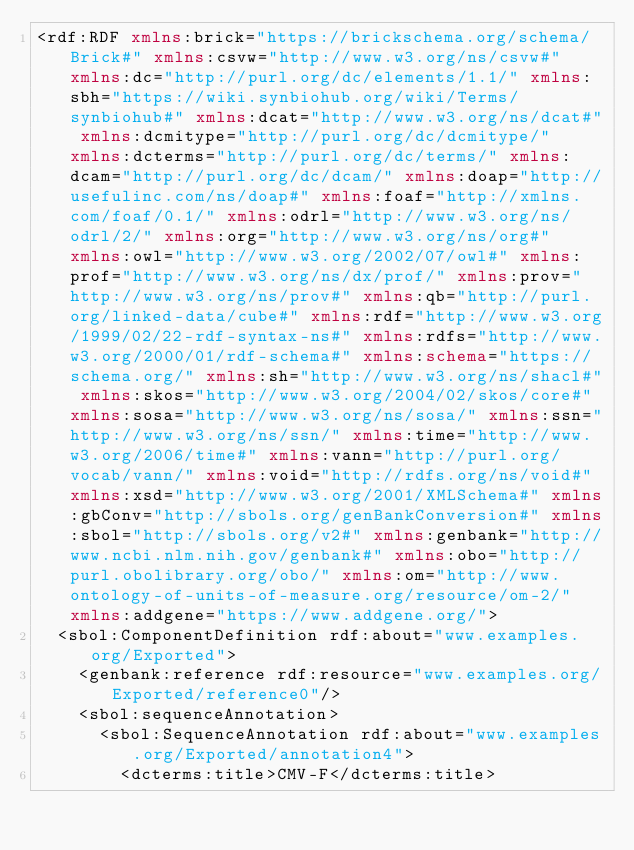<code> <loc_0><loc_0><loc_500><loc_500><_XML_><rdf:RDF xmlns:brick="https://brickschema.org/schema/Brick#" xmlns:csvw="http://www.w3.org/ns/csvw#" xmlns:dc="http://purl.org/dc/elements/1.1/" xmlns:sbh="https://wiki.synbiohub.org/wiki/Terms/synbiohub#" xmlns:dcat="http://www.w3.org/ns/dcat#" xmlns:dcmitype="http://purl.org/dc/dcmitype/" xmlns:dcterms="http://purl.org/dc/terms/" xmlns:dcam="http://purl.org/dc/dcam/" xmlns:doap="http://usefulinc.com/ns/doap#" xmlns:foaf="http://xmlns.com/foaf/0.1/" xmlns:odrl="http://www.w3.org/ns/odrl/2/" xmlns:org="http://www.w3.org/ns/org#" xmlns:owl="http://www.w3.org/2002/07/owl#" xmlns:prof="http://www.w3.org/ns/dx/prof/" xmlns:prov="http://www.w3.org/ns/prov#" xmlns:qb="http://purl.org/linked-data/cube#" xmlns:rdf="http://www.w3.org/1999/02/22-rdf-syntax-ns#" xmlns:rdfs="http://www.w3.org/2000/01/rdf-schema#" xmlns:schema="https://schema.org/" xmlns:sh="http://www.w3.org/ns/shacl#" xmlns:skos="http://www.w3.org/2004/02/skos/core#" xmlns:sosa="http://www.w3.org/ns/sosa/" xmlns:ssn="http://www.w3.org/ns/ssn/" xmlns:time="http://www.w3.org/2006/time#" xmlns:vann="http://purl.org/vocab/vann/" xmlns:void="http://rdfs.org/ns/void#" xmlns:xsd="http://www.w3.org/2001/XMLSchema#" xmlns:gbConv="http://sbols.org/genBankConversion#" xmlns:sbol="http://sbols.org/v2#" xmlns:genbank="http://www.ncbi.nlm.nih.gov/genbank#" xmlns:obo="http://purl.obolibrary.org/obo/" xmlns:om="http://www.ontology-of-units-of-measure.org/resource/om-2/" xmlns:addgene="https://www.addgene.org/">
  <sbol:ComponentDefinition rdf:about="www.examples.org/Exported">
    <genbank:reference rdf:resource="www.examples.org/Exported/reference0"/>
    <sbol:sequenceAnnotation>
      <sbol:SequenceAnnotation rdf:about="www.examples.org/Exported/annotation4">
        <dcterms:title>CMV-F</dcterms:title></code> 